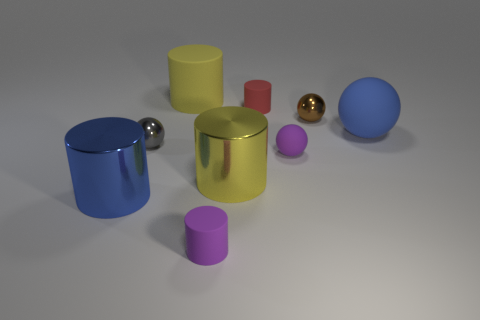Subtract all big yellow cylinders. How many cylinders are left? 3 Subtract 5 cylinders. How many cylinders are left? 0 Subtract all brown blocks. How many yellow cylinders are left? 2 Add 8 tiny brown balls. How many tiny brown balls exist? 9 Subtract all yellow cylinders. How many cylinders are left? 3 Subtract 1 brown spheres. How many objects are left? 8 Subtract all cylinders. How many objects are left? 4 Subtract all green spheres. Subtract all gray cubes. How many spheres are left? 4 Subtract all gray cylinders. Subtract all tiny cylinders. How many objects are left? 7 Add 8 purple rubber balls. How many purple rubber balls are left? 9 